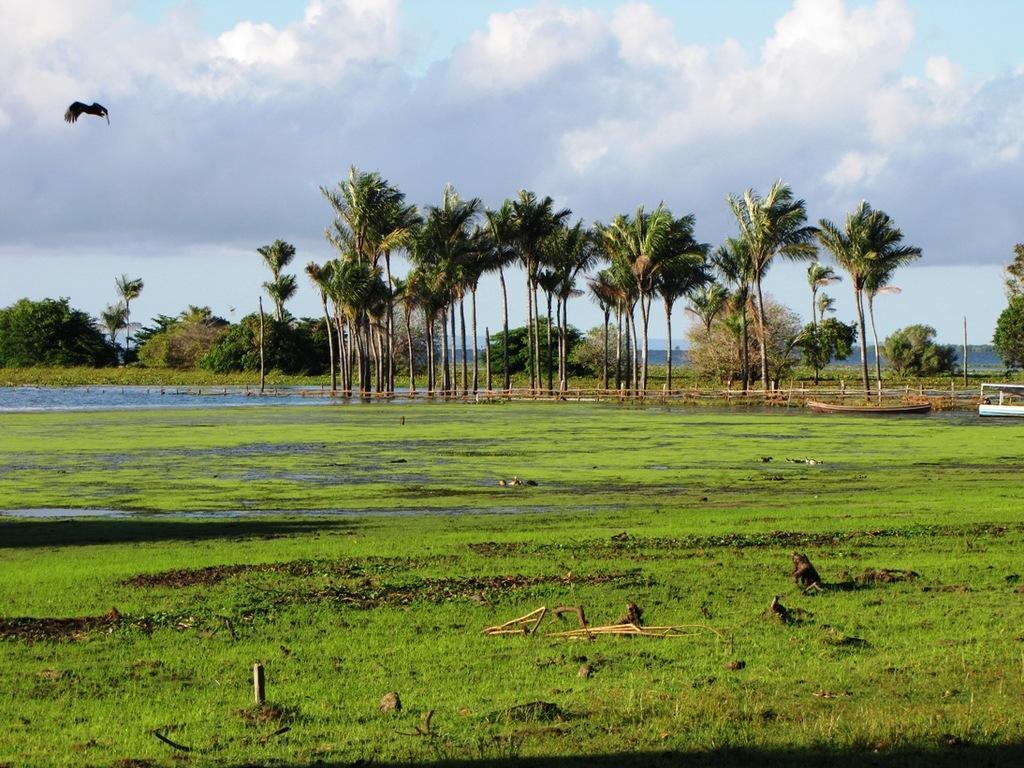In one or two sentences, can you explain what this image depicts? In this image, we can see so many trees. Here at the bottom, we can see a water, grass. Right side of the image, we can see few boats. Top of the image, there is a cloudy sky. Here a bird is flying. 